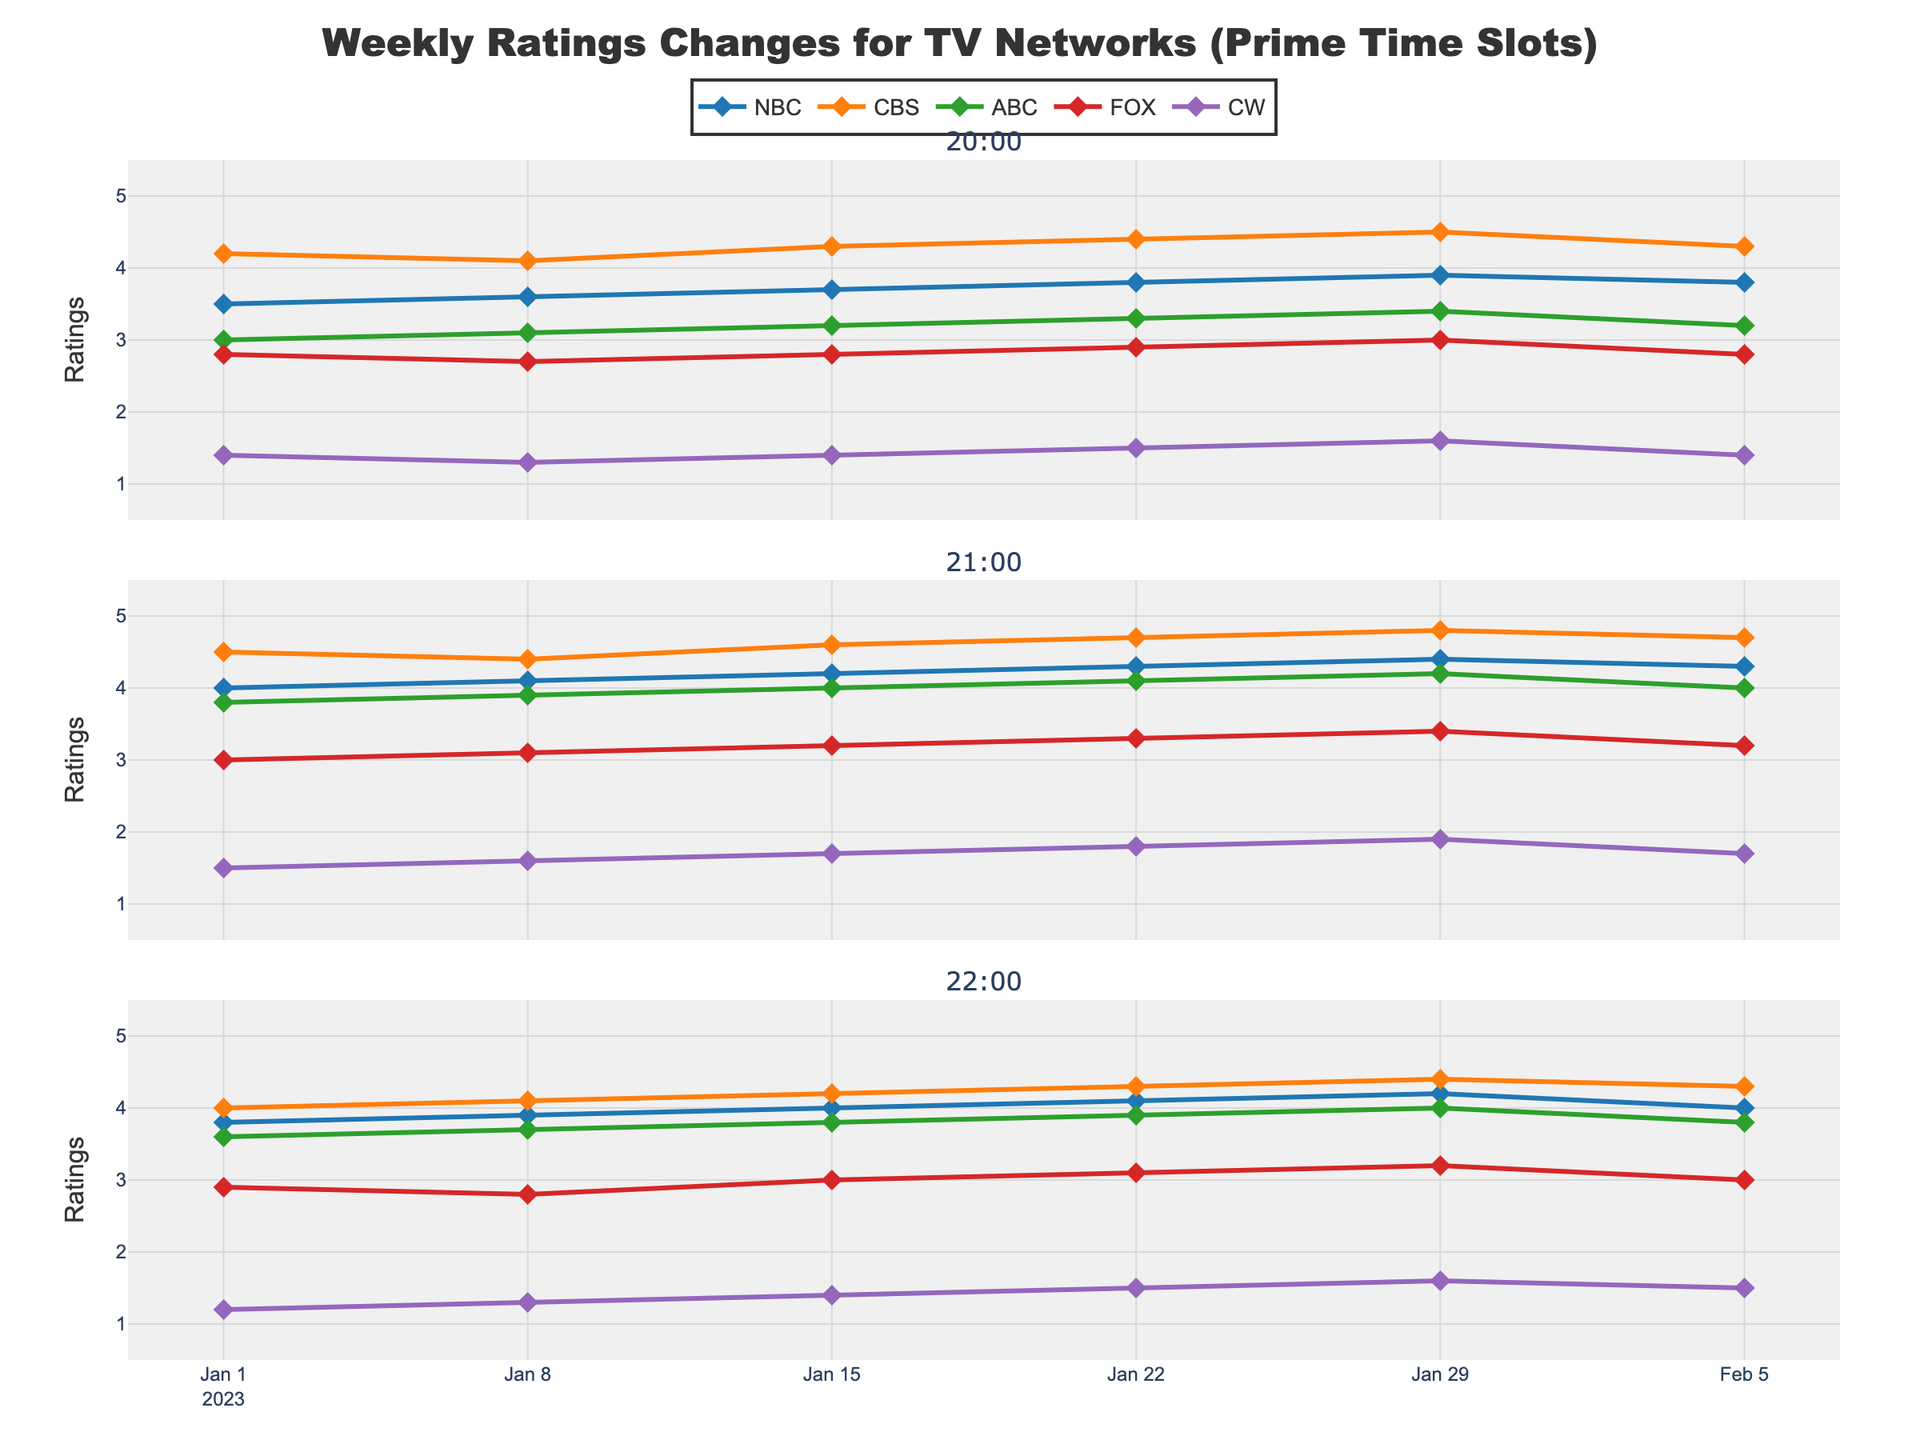What is the title of the figure? The title of the figure is located at the top center of the plot, usually in a larger and bolder font than the rest of the text. It helps to quickly understand the main theme of the figure.
Answer: Weekly Ratings Changes for TV Networks (Prime Time Slots) Which network has the highest rating at 21:00 on January 22, 2023? To find this, look at the data for the 21:00 time slot on January 22, 2023, and compare the ratings for all networks at that time.
Answer: CBS What is the range of the ratings axis? The range of the ratings axis can be observed on the y-axis of the plot, which shows the minimum and maximum values of the ratings presented.
Answer: 0.5 to 5.5 How do the ratings for NBC change from 20:00 to 22:00 on January 15, 2023? To answer this, list the ratings for NBC at 20:00, 21:00, and 22:00 on January 15, 2023, and observe the changes as the time progresses.
Answer: 3.7, 4.2, 4.0 Which network shows consistent improvement in ratings over the weeks at 21:00? To determine this, observe the ratings trend for each network over consecutive weeks only at the 21:00 slot. Look for a network whose ratings increase consistently week-to-week.
Answer: NBC What is the average rating of ABC at 21:00 across all given dates? Calculate the average rating of ABC at the 21:00 time slot by summing all ratings provided for this slot and dividing by the number of weeks. (3.8+3.9+4.0+4.1+4.2+4.0)/6 = 4.0
Answer: 4.0 Which network had the lowest rating at 22:00 on February 5, 2023? Look at the ratings for all networks at the 22:00 time slot on February 5, 2023, and identify the network with the smallest value.
Answer: CW How many time slots are displayed in this figure? Count the number of subplot titles or charts displaying data, each representing a different time slot.
Answer: 3 Between NBC and CBS, which network had more stable ratings at 20:00 during January? To determine stability, examine the ratings for NBC and CBS at 20:00 across all January dates and see which network had smaller fluctuations in their ratings.
Answer: CBS What is the trend of FOX ratings at 20:00 over the given time period? To identify the trend, look at the ratings of FOX for the 20:00 slot from the earliest date to the latest, and describe whether the ratings generally increase, decrease, or remain stable.
Answer: Mostly stable with slight variations 